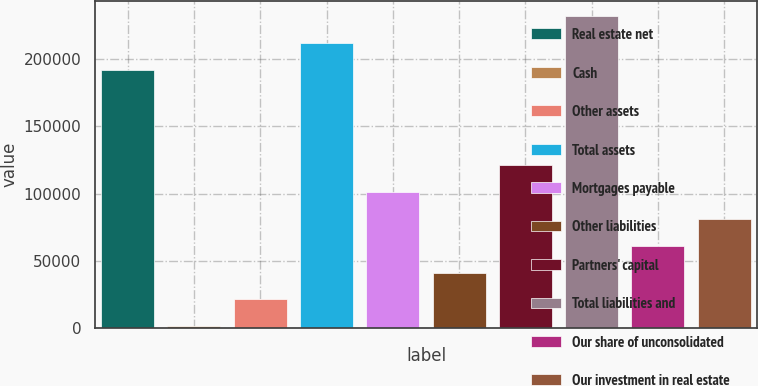Convert chart. <chart><loc_0><loc_0><loc_500><loc_500><bar_chart><fcel>Real estate net<fcel>Cash<fcel>Other assets<fcel>Total assets<fcel>Mortgages payable<fcel>Other liabilities<fcel>Partners' capital<fcel>Total liabilities and<fcel>Our share of unconsolidated<fcel>Our investment in real estate<nl><fcel>191747<fcel>1453<fcel>21345<fcel>211639<fcel>100913<fcel>41237<fcel>120805<fcel>231531<fcel>61129<fcel>81021<nl></chart> 